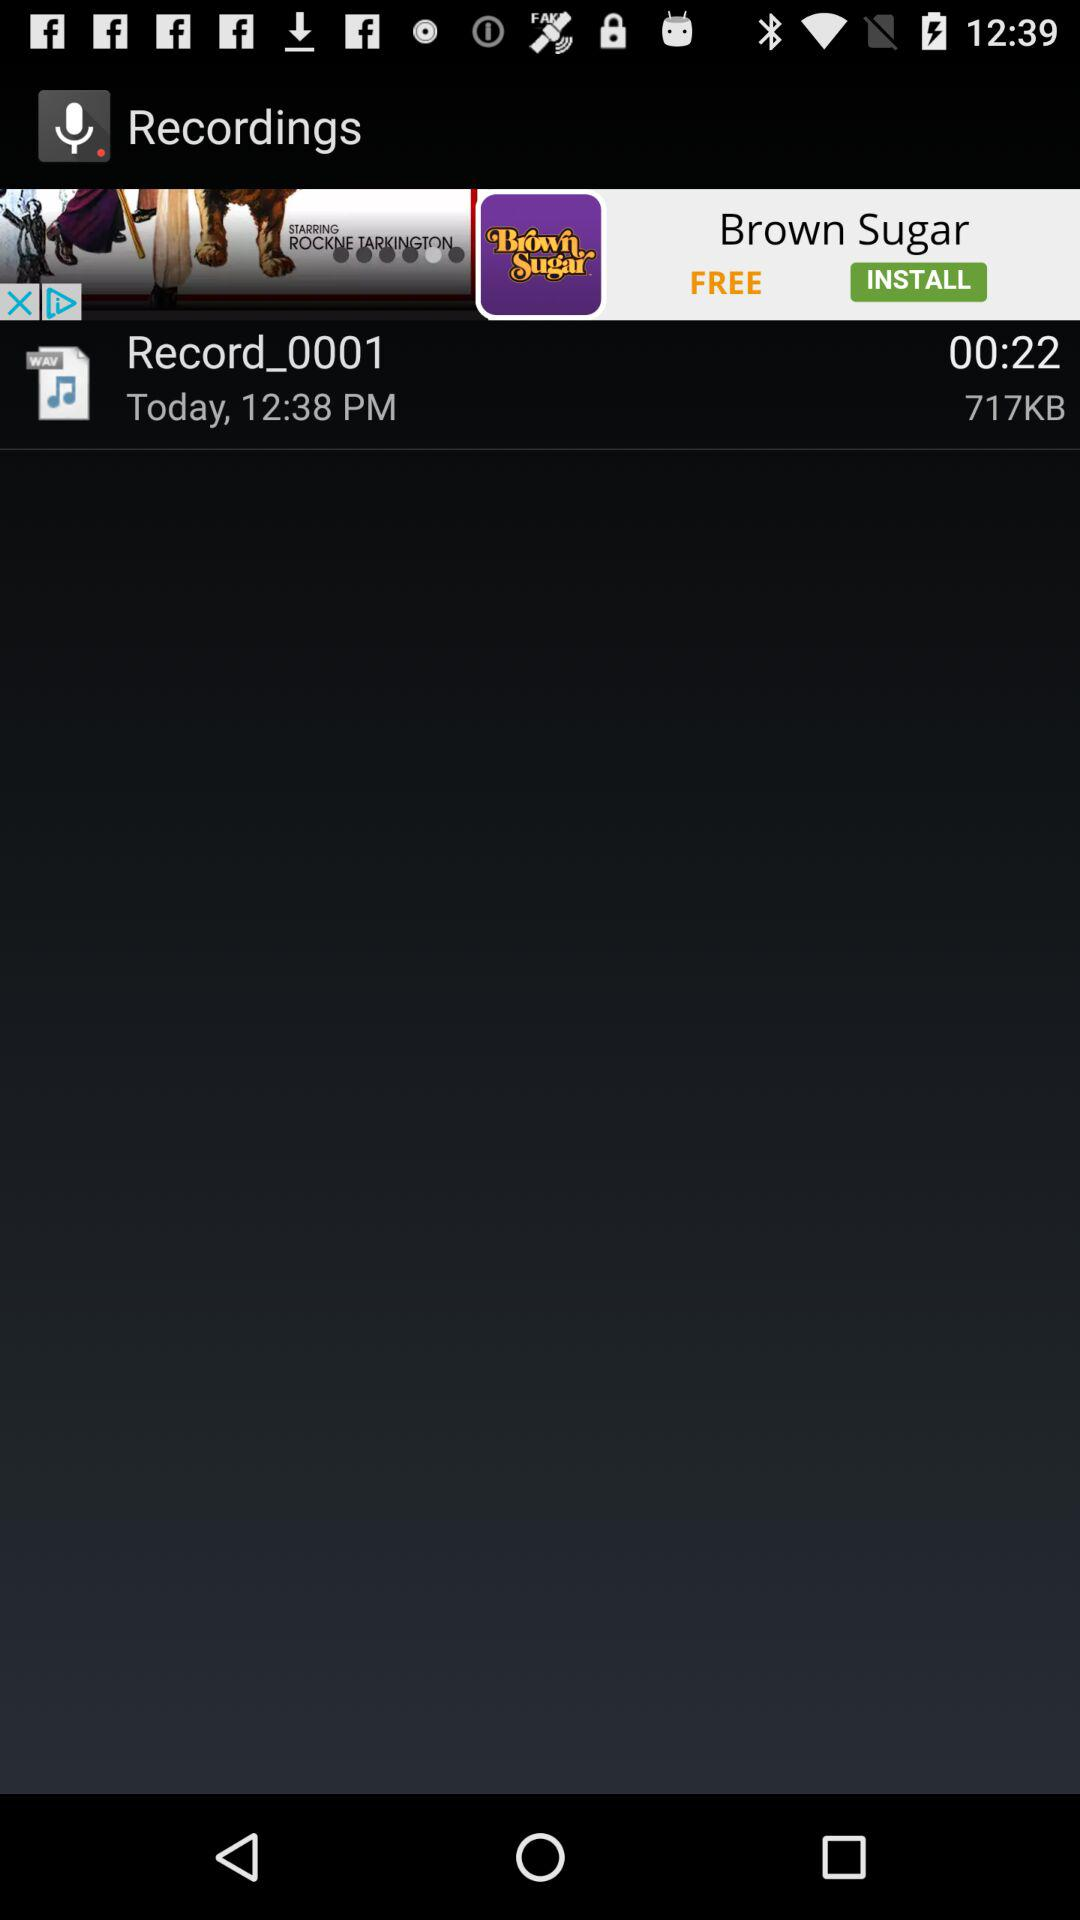What is the given time of recording? The given time is today at 12:38 pm. 